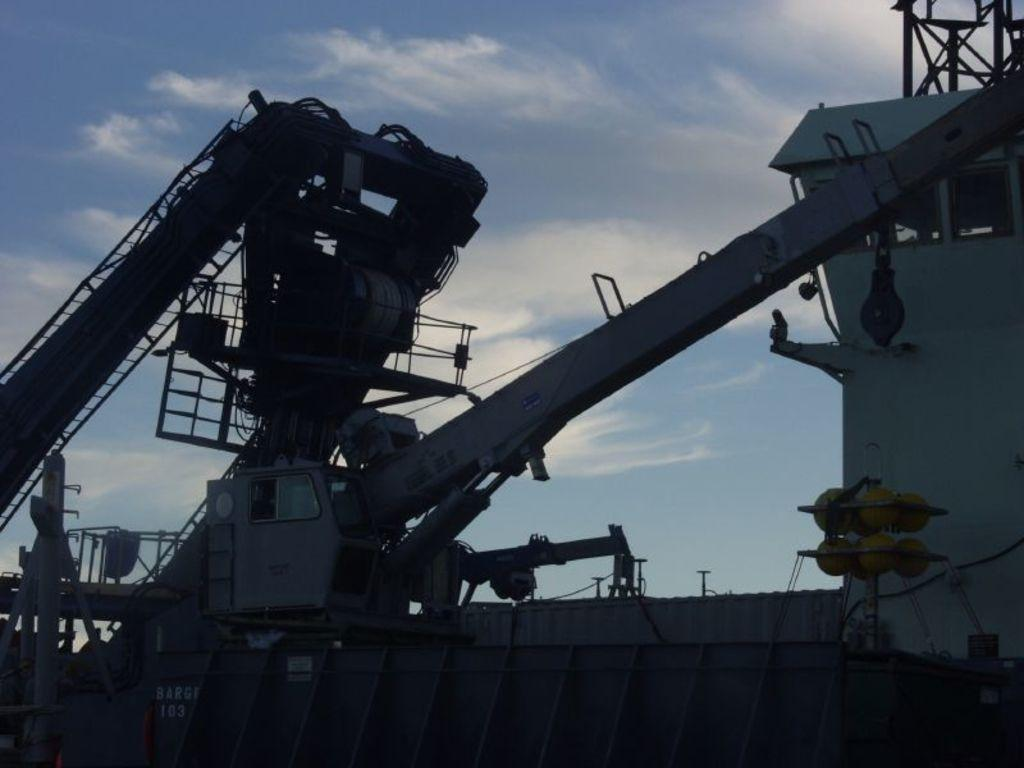What is the main subject of the picture? The main subject of the picture is a ship. What can be seen on the ship? There is a rope, text, and a poster on the ship. What is visible at the top of the image? The sky is visible at the top of the image. What can be observed in the sky? There are clouds in the sky. What verse is being recited by the maid in the image? There is no maid or verse present in the image. What type of food is being served on the ship in the image? There is no food visible in the image. 